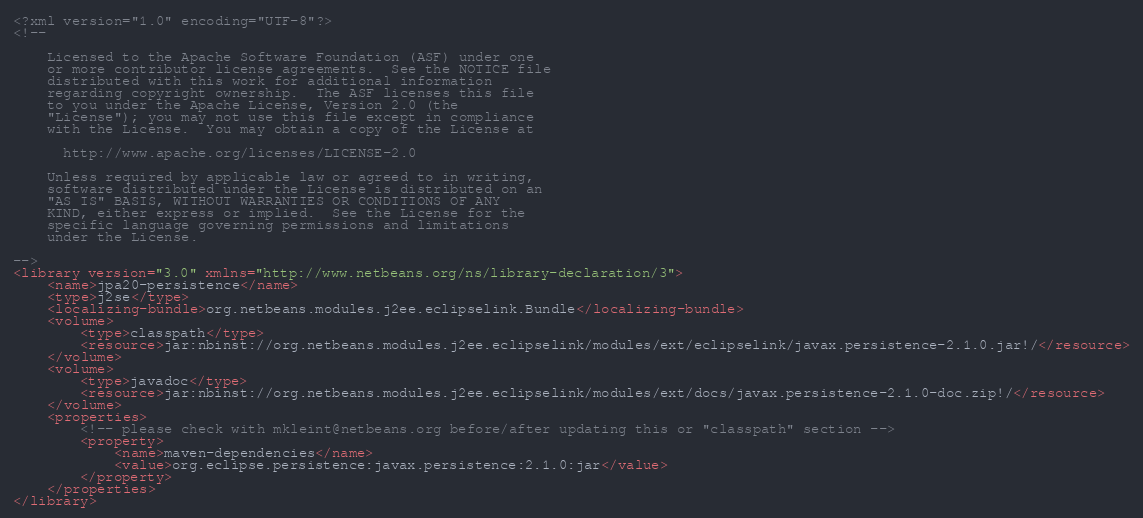<code> <loc_0><loc_0><loc_500><loc_500><_XML_><?xml version="1.0" encoding="UTF-8"?>
<!--

    Licensed to the Apache Software Foundation (ASF) under one
    or more contributor license agreements.  See the NOTICE file
    distributed with this work for additional information
    regarding copyright ownership.  The ASF licenses this file
    to you under the Apache License, Version 2.0 (the
    "License"); you may not use this file except in compliance
    with the License.  You may obtain a copy of the License at

      http://www.apache.org/licenses/LICENSE-2.0

    Unless required by applicable law or agreed to in writing,
    software distributed under the License is distributed on an
    "AS IS" BASIS, WITHOUT WARRANTIES OR CONDITIONS OF ANY
    KIND, either express or implied.  See the License for the
    specific language governing permissions and limitations
    under the License.

-->
<library version="3.0" xmlns="http://www.netbeans.org/ns/library-declaration/3">
    <name>jpa20-persistence</name>
    <type>j2se</type>
    <localizing-bundle>org.netbeans.modules.j2ee.eclipselink.Bundle</localizing-bundle>
    <volume>
        <type>classpath</type>
        <resource>jar:nbinst://org.netbeans.modules.j2ee.eclipselink/modules/ext/eclipselink/javax.persistence-2.1.0.jar!/</resource>
    </volume>
    <volume>
        <type>javadoc</type>
        <resource>jar:nbinst://org.netbeans.modules.j2ee.eclipselink/modules/ext/docs/javax.persistence-2.1.0-doc.zip!/</resource>
    </volume>
    <properties>
        <!-- please check with mkleint@netbeans.org before/after updating this or "classpath" section -->
        <property>
            <name>maven-dependencies</name>
            <value>org.eclipse.persistence:javax.persistence:2.1.0:jar</value>
        </property>
    </properties>
</library>
</code> 